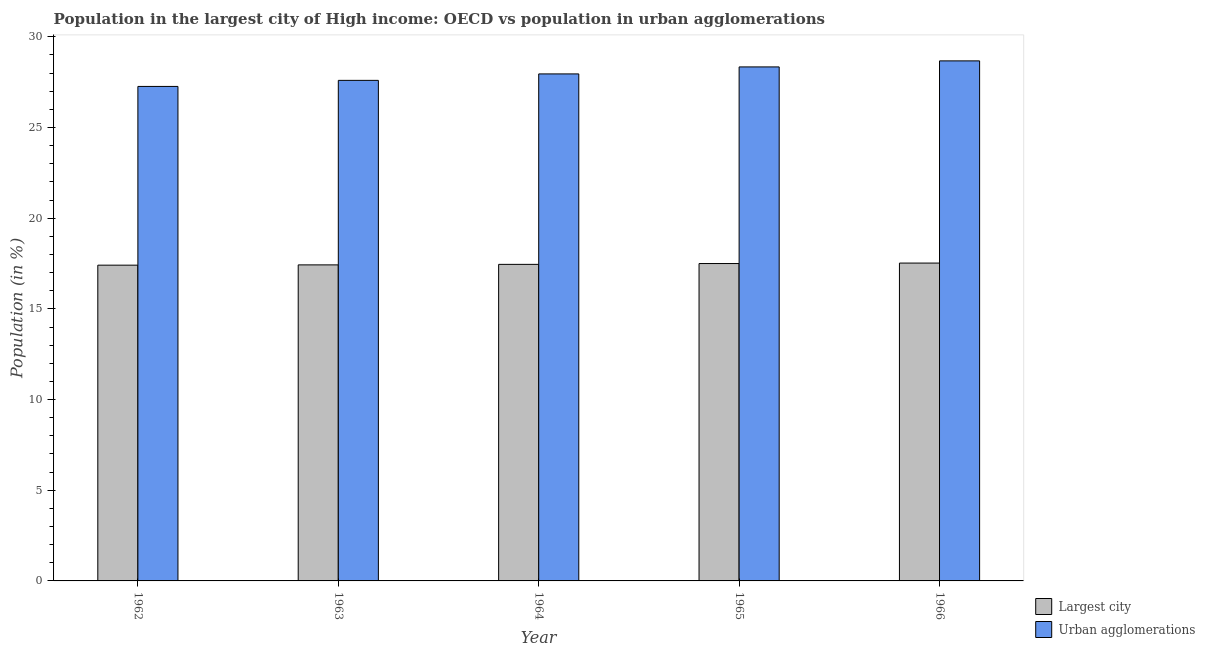How many groups of bars are there?
Keep it short and to the point. 5. Are the number of bars on each tick of the X-axis equal?
Provide a succinct answer. Yes. How many bars are there on the 5th tick from the left?
Provide a succinct answer. 2. How many bars are there on the 4th tick from the right?
Your answer should be compact. 2. What is the label of the 4th group of bars from the left?
Your response must be concise. 1965. In how many cases, is the number of bars for a given year not equal to the number of legend labels?
Give a very brief answer. 0. What is the population in urban agglomerations in 1962?
Provide a short and direct response. 27.27. Across all years, what is the maximum population in urban agglomerations?
Offer a very short reply. 28.68. Across all years, what is the minimum population in urban agglomerations?
Give a very brief answer. 27.27. In which year was the population in urban agglomerations maximum?
Ensure brevity in your answer.  1966. What is the total population in the largest city in the graph?
Your answer should be very brief. 87.32. What is the difference between the population in urban agglomerations in 1962 and that in 1964?
Your answer should be very brief. -0.69. What is the difference between the population in the largest city in 1965 and the population in urban agglomerations in 1962?
Give a very brief answer. 0.09. What is the average population in the largest city per year?
Offer a terse response. 17.46. In the year 1966, what is the difference between the population in the largest city and population in urban agglomerations?
Ensure brevity in your answer.  0. In how many years, is the population in urban agglomerations greater than 25 %?
Ensure brevity in your answer.  5. What is the ratio of the population in urban agglomerations in 1964 to that in 1966?
Offer a very short reply. 0.97. Is the population in the largest city in 1963 less than that in 1965?
Make the answer very short. Yes. What is the difference between the highest and the second highest population in the largest city?
Offer a terse response. 0.03. What is the difference between the highest and the lowest population in the largest city?
Give a very brief answer. 0.12. In how many years, is the population in urban agglomerations greater than the average population in urban agglomerations taken over all years?
Keep it short and to the point. 2. Is the sum of the population in urban agglomerations in 1963 and 1965 greater than the maximum population in the largest city across all years?
Your response must be concise. Yes. What does the 1st bar from the left in 1963 represents?
Provide a succinct answer. Largest city. What does the 1st bar from the right in 1964 represents?
Give a very brief answer. Urban agglomerations. Are all the bars in the graph horizontal?
Offer a terse response. No. How many years are there in the graph?
Your response must be concise. 5. What is the difference between two consecutive major ticks on the Y-axis?
Give a very brief answer. 5. Where does the legend appear in the graph?
Offer a very short reply. Bottom right. What is the title of the graph?
Make the answer very short. Population in the largest city of High income: OECD vs population in urban agglomerations. What is the label or title of the Y-axis?
Provide a succinct answer. Population (in %). What is the Population (in %) in Largest city in 1962?
Offer a very short reply. 17.41. What is the Population (in %) of Urban agglomerations in 1962?
Ensure brevity in your answer.  27.27. What is the Population (in %) of Largest city in 1963?
Your answer should be very brief. 17.43. What is the Population (in %) in Urban agglomerations in 1963?
Your response must be concise. 27.6. What is the Population (in %) in Largest city in 1964?
Give a very brief answer. 17.46. What is the Population (in %) of Urban agglomerations in 1964?
Make the answer very short. 27.96. What is the Population (in %) in Largest city in 1965?
Keep it short and to the point. 17.5. What is the Population (in %) in Urban agglomerations in 1965?
Offer a very short reply. 28.34. What is the Population (in %) of Largest city in 1966?
Your answer should be compact. 17.53. What is the Population (in %) in Urban agglomerations in 1966?
Your response must be concise. 28.68. Across all years, what is the maximum Population (in %) in Largest city?
Offer a very short reply. 17.53. Across all years, what is the maximum Population (in %) of Urban agglomerations?
Offer a very short reply. 28.68. Across all years, what is the minimum Population (in %) of Largest city?
Give a very brief answer. 17.41. Across all years, what is the minimum Population (in %) in Urban agglomerations?
Your answer should be compact. 27.27. What is the total Population (in %) of Largest city in the graph?
Your response must be concise. 87.32. What is the total Population (in %) of Urban agglomerations in the graph?
Provide a succinct answer. 139.84. What is the difference between the Population (in %) in Largest city in 1962 and that in 1963?
Offer a very short reply. -0.02. What is the difference between the Population (in %) in Urban agglomerations in 1962 and that in 1963?
Keep it short and to the point. -0.33. What is the difference between the Population (in %) in Largest city in 1962 and that in 1964?
Offer a very short reply. -0.04. What is the difference between the Population (in %) in Urban agglomerations in 1962 and that in 1964?
Offer a very short reply. -0.69. What is the difference between the Population (in %) of Largest city in 1962 and that in 1965?
Offer a very short reply. -0.09. What is the difference between the Population (in %) in Urban agglomerations in 1962 and that in 1965?
Keep it short and to the point. -1.08. What is the difference between the Population (in %) of Largest city in 1962 and that in 1966?
Keep it short and to the point. -0.12. What is the difference between the Population (in %) in Urban agglomerations in 1962 and that in 1966?
Ensure brevity in your answer.  -1.41. What is the difference between the Population (in %) in Largest city in 1963 and that in 1964?
Your response must be concise. -0.03. What is the difference between the Population (in %) in Urban agglomerations in 1963 and that in 1964?
Give a very brief answer. -0.36. What is the difference between the Population (in %) in Largest city in 1963 and that in 1965?
Your response must be concise. -0.07. What is the difference between the Population (in %) in Urban agglomerations in 1963 and that in 1965?
Ensure brevity in your answer.  -0.74. What is the difference between the Population (in %) in Largest city in 1963 and that in 1966?
Your response must be concise. -0.1. What is the difference between the Population (in %) of Urban agglomerations in 1963 and that in 1966?
Ensure brevity in your answer.  -1.07. What is the difference between the Population (in %) of Largest city in 1964 and that in 1965?
Keep it short and to the point. -0.05. What is the difference between the Population (in %) of Urban agglomerations in 1964 and that in 1965?
Your response must be concise. -0.39. What is the difference between the Population (in %) of Largest city in 1964 and that in 1966?
Your response must be concise. -0.07. What is the difference between the Population (in %) in Urban agglomerations in 1964 and that in 1966?
Provide a succinct answer. -0.72. What is the difference between the Population (in %) of Largest city in 1965 and that in 1966?
Your response must be concise. -0.03. What is the difference between the Population (in %) of Urban agglomerations in 1965 and that in 1966?
Keep it short and to the point. -0.33. What is the difference between the Population (in %) of Largest city in 1962 and the Population (in %) of Urban agglomerations in 1963?
Provide a short and direct response. -10.19. What is the difference between the Population (in %) of Largest city in 1962 and the Population (in %) of Urban agglomerations in 1964?
Provide a succinct answer. -10.55. What is the difference between the Population (in %) in Largest city in 1962 and the Population (in %) in Urban agglomerations in 1965?
Provide a short and direct response. -10.93. What is the difference between the Population (in %) of Largest city in 1962 and the Population (in %) of Urban agglomerations in 1966?
Your answer should be compact. -11.26. What is the difference between the Population (in %) of Largest city in 1963 and the Population (in %) of Urban agglomerations in 1964?
Your response must be concise. -10.53. What is the difference between the Population (in %) in Largest city in 1963 and the Population (in %) in Urban agglomerations in 1965?
Make the answer very short. -10.92. What is the difference between the Population (in %) of Largest city in 1963 and the Population (in %) of Urban agglomerations in 1966?
Your answer should be very brief. -11.25. What is the difference between the Population (in %) in Largest city in 1964 and the Population (in %) in Urban agglomerations in 1965?
Your answer should be compact. -10.89. What is the difference between the Population (in %) of Largest city in 1964 and the Population (in %) of Urban agglomerations in 1966?
Provide a short and direct response. -11.22. What is the difference between the Population (in %) of Largest city in 1965 and the Population (in %) of Urban agglomerations in 1966?
Give a very brief answer. -11.17. What is the average Population (in %) in Largest city per year?
Offer a very short reply. 17.46. What is the average Population (in %) in Urban agglomerations per year?
Your response must be concise. 27.97. In the year 1962, what is the difference between the Population (in %) of Largest city and Population (in %) of Urban agglomerations?
Offer a very short reply. -9.86. In the year 1963, what is the difference between the Population (in %) of Largest city and Population (in %) of Urban agglomerations?
Provide a succinct answer. -10.17. In the year 1964, what is the difference between the Population (in %) of Largest city and Population (in %) of Urban agglomerations?
Your answer should be very brief. -10.5. In the year 1965, what is the difference between the Population (in %) in Largest city and Population (in %) in Urban agglomerations?
Your answer should be compact. -10.84. In the year 1966, what is the difference between the Population (in %) of Largest city and Population (in %) of Urban agglomerations?
Give a very brief answer. -11.15. What is the ratio of the Population (in %) of Urban agglomerations in 1962 to that in 1963?
Make the answer very short. 0.99. What is the ratio of the Population (in %) in Urban agglomerations in 1962 to that in 1964?
Offer a terse response. 0.98. What is the ratio of the Population (in %) in Urban agglomerations in 1962 to that in 1965?
Your answer should be very brief. 0.96. What is the ratio of the Population (in %) of Urban agglomerations in 1962 to that in 1966?
Your answer should be compact. 0.95. What is the ratio of the Population (in %) in Largest city in 1963 to that in 1964?
Your response must be concise. 1. What is the ratio of the Population (in %) of Urban agglomerations in 1963 to that in 1964?
Ensure brevity in your answer.  0.99. What is the ratio of the Population (in %) of Urban agglomerations in 1963 to that in 1965?
Provide a succinct answer. 0.97. What is the ratio of the Population (in %) in Largest city in 1963 to that in 1966?
Provide a short and direct response. 0.99. What is the ratio of the Population (in %) of Urban agglomerations in 1963 to that in 1966?
Provide a succinct answer. 0.96. What is the ratio of the Population (in %) of Largest city in 1964 to that in 1965?
Ensure brevity in your answer.  1. What is the ratio of the Population (in %) of Urban agglomerations in 1964 to that in 1965?
Make the answer very short. 0.99. What is the ratio of the Population (in %) in Urban agglomerations in 1964 to that in 1966?
Give a very brief answer. 0.97. What is the ratio of the Population (in %) in Largest city in 1965 to that in 1966?
Offer a very short reply. 1. What is the ratio of the Population (in %) in Urban agglomerations in 1965 to that in 1966?
Your answer should be compact. 0.99. What is the difference between the highest and the second highest Population (in %) of Largest city?
Provide a succinct answer. 0.03. What is the difference between the highest and the second highest Population (in %) in Urban agglomerations?
Make the answer very short. 0.33. What is the difference between the highest and the lowest Population (in %) in Largest city?
Ensure brevity in your answer.  0.12. What is the difference between the highest and the lowest Population (in %) of Urban agglomerations?
Offer a terse response. 1.41. 